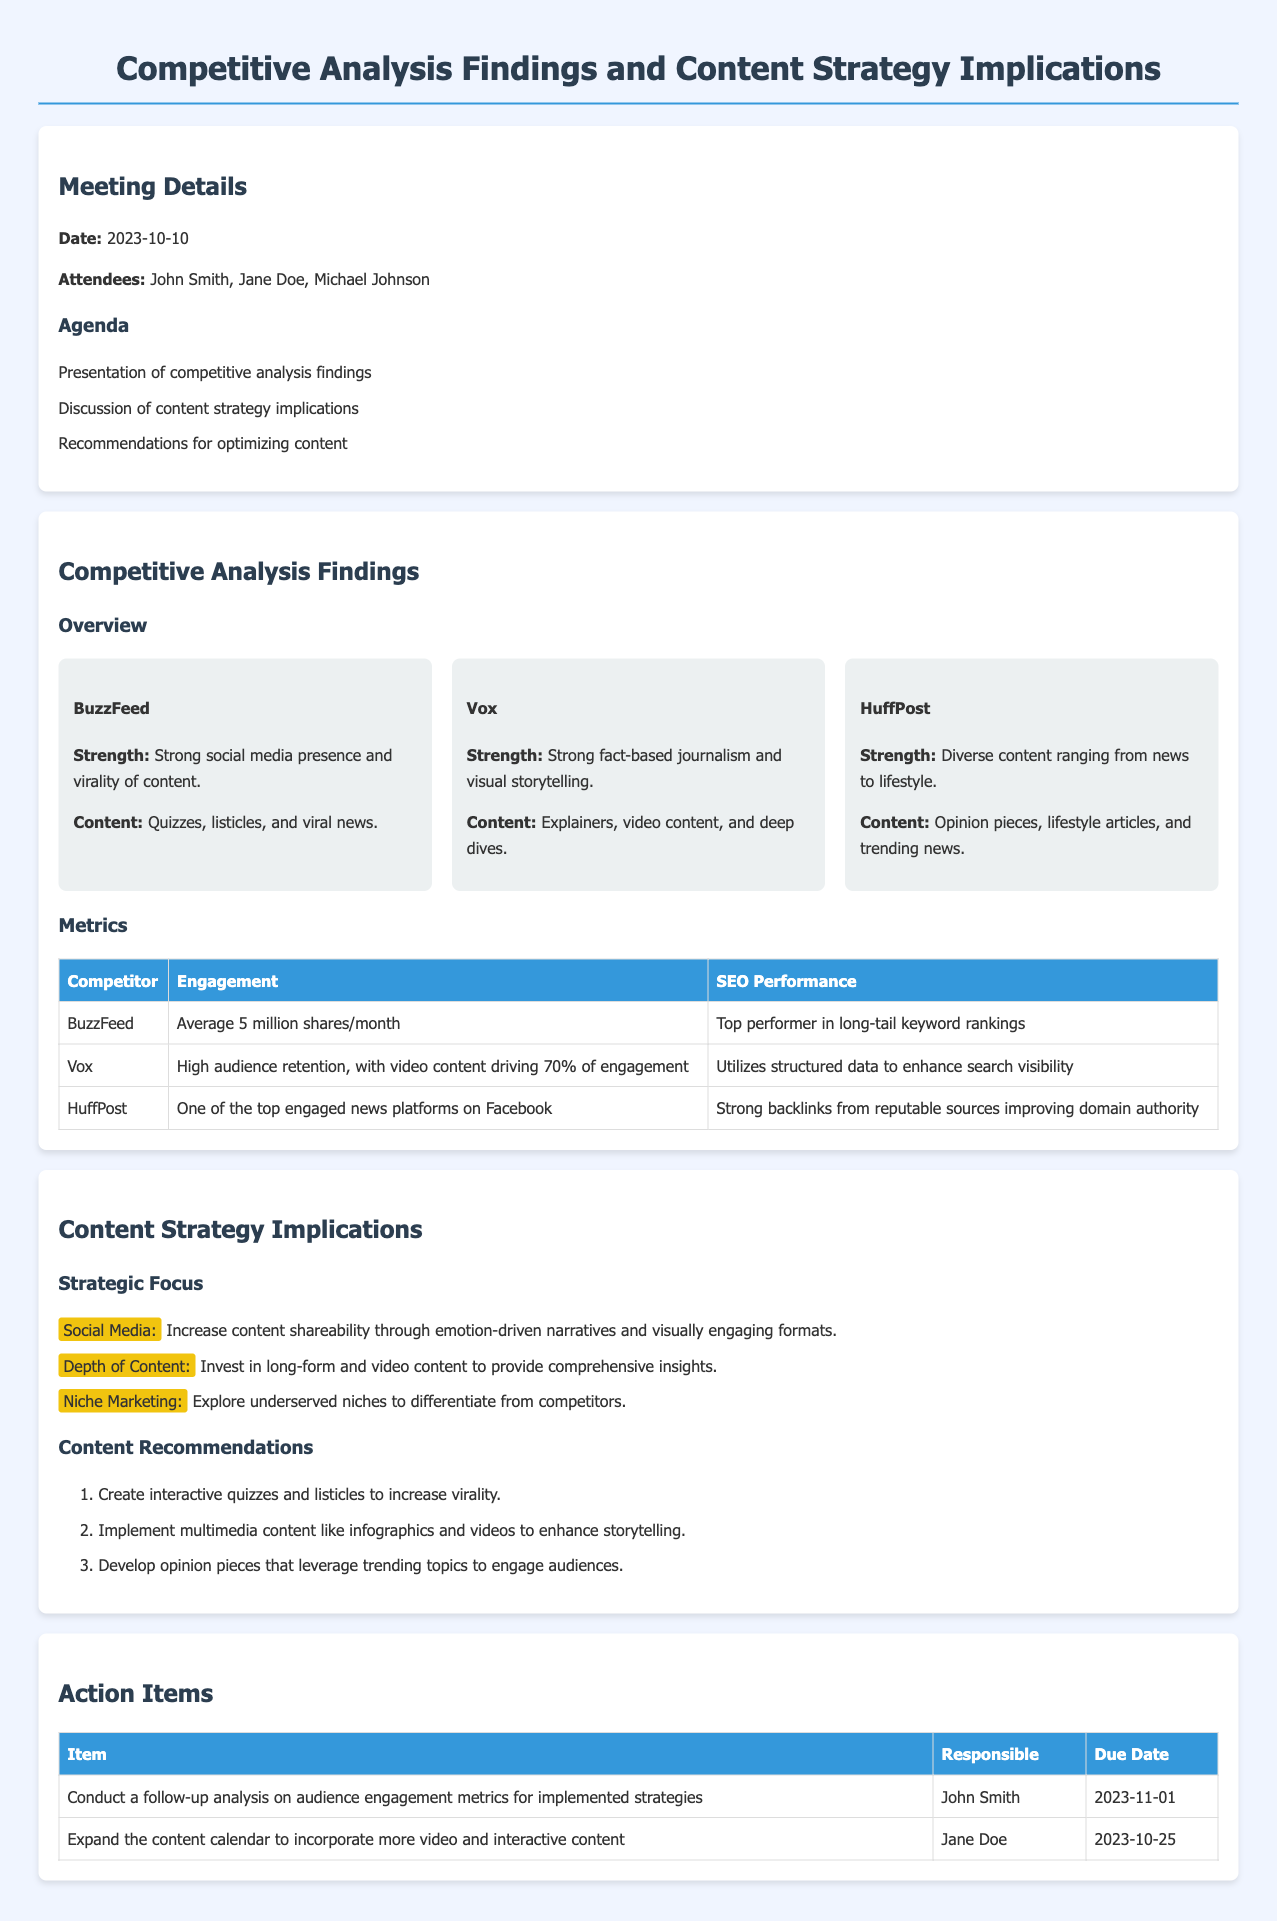What is the date of the meeting? The date of the meeting is directly stated in the document under Meeting Details.
Answer: 2023-10-10 Who is responsible for expanding the content calendar? The person's name is mentioned in the Action Items section of the document.
Answer: Jane Doe How many items are listed in the Content Recommendations? The total number of items can be counted from the ordered list in the document.
Answer: 3 What is BuzzFeed's average engagement? Average engagement is mentioned in the Metrics section as stated in the document.
Answer: Average 5 million shares/month What content type drives 70% of Vox's engagement? This information can be found in the Metrics table regarding engagement for Vox.
Answer: Video content What is one of the strengths of HuffPost? The strengths of HuffPost are specified in the Competitive Analysis Findings section.
Answer: Diverse content ranging from news to lifestyle What is the due date for the follow-up analysis? This date is specified in the Due Date column of the Action Items table.
Answer: 2023-11-01 What number of attendees is listed in the meeting? The number of people present at the meeting is given in the Meeting Details section.
Answer: 3 